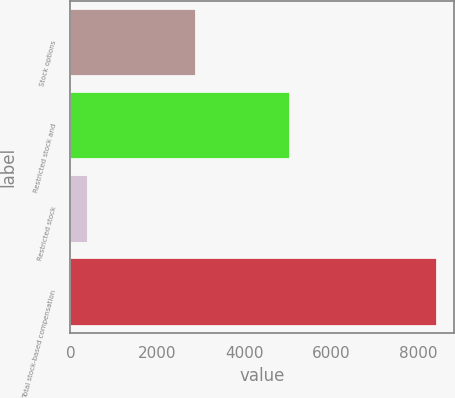Convert chart. <chart><loc_0><loc_0><loc_500><loc_500><bar_chart><fcel>Stock options<fcel>Restricted stock and<fcel>Restricted stock<fcel>Total stock-based compensation<nl><fcel>2858<fcel>5040<fcel>373<fcel>8414<nl></chart> 